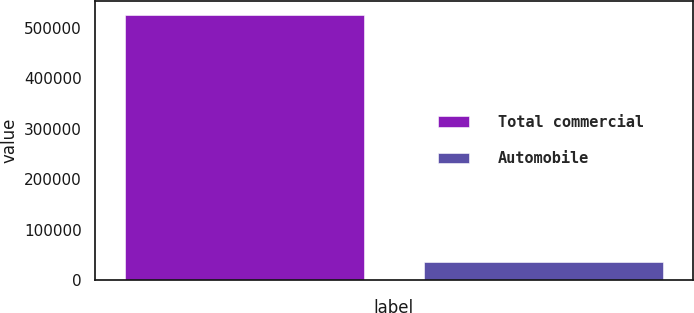<chart> <loc_0><loc_0><loc_500><loc_500><bar_chart><fcel>Total commercial<fcel>Automobile<nl><fcel>526420<fcel>34979<nl></chart> 